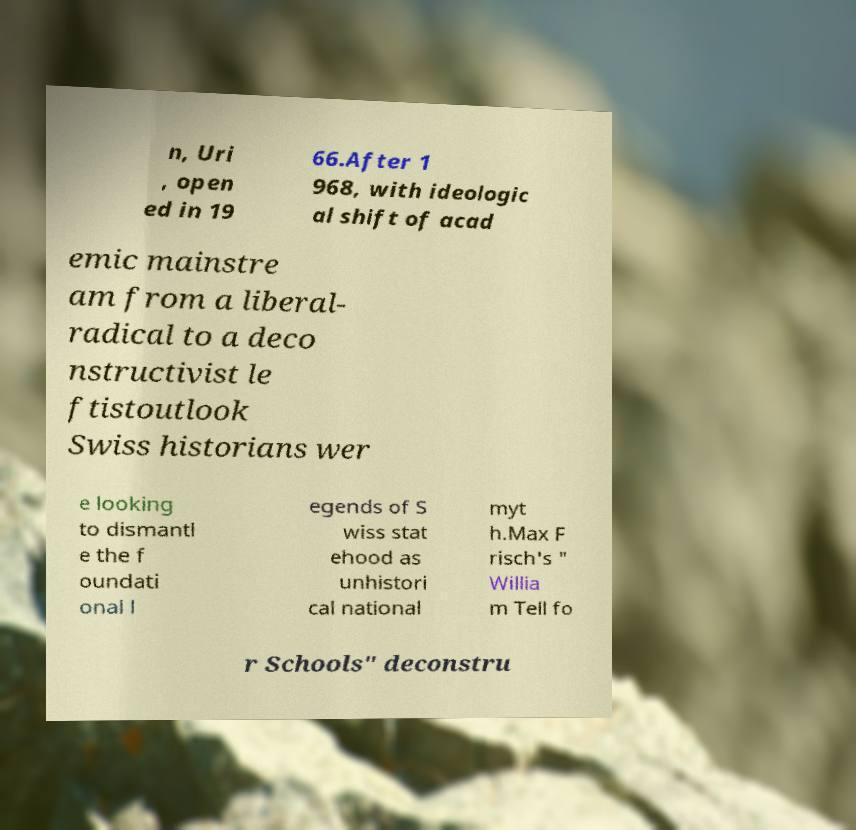Please identify and transcribe the text found in this image. n, Uri , open ed in 19 66.After 1 968, with ideologic al shift of acad emic mainstre am from a liberal- radical to a deco nstructivist le ftistoutlook Swiss historians wer e looking to dismantl e the f oundati onal l egends of S wiss stat ehood as unhistori cal national myt h.Max F risch's " Willia m Tell fo r Schools" deconstru 